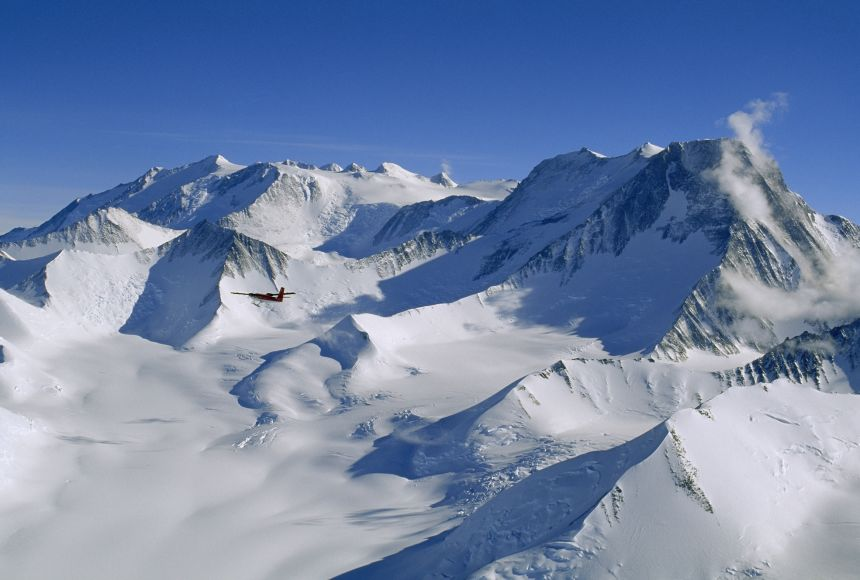What do you see happening in this image? The image beautifully captures an aerial view of Vinson Massif, the highest peak in Antarctica. You can see the majestic, snow-covered mountains under a mostly clear, azure sky. Noteworthy is the small red airplane flying above, providing a stark color contrast to the icy whites and blues of the frozen landscape. This rare perspective not only emphasizes the vastness and the untouched beauty of this remote area but also highlights human exploration in such extreme conditions. 